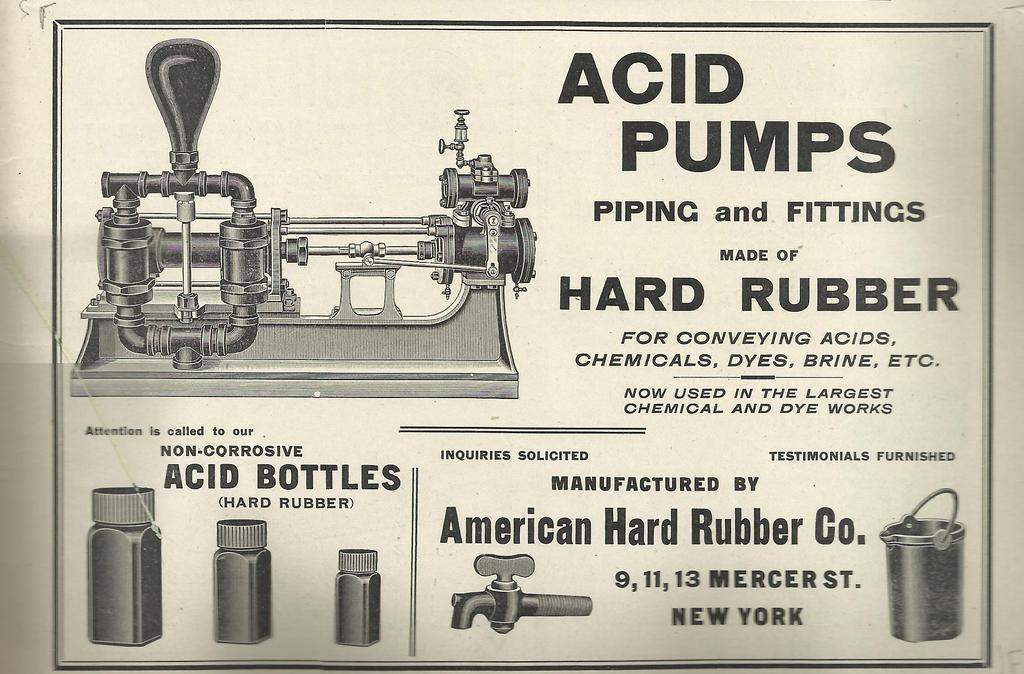<image>
Relay a brief, clear account of the picture shown. A black and white advertisement for American Hard Rubber Co advertising acid pumps. 